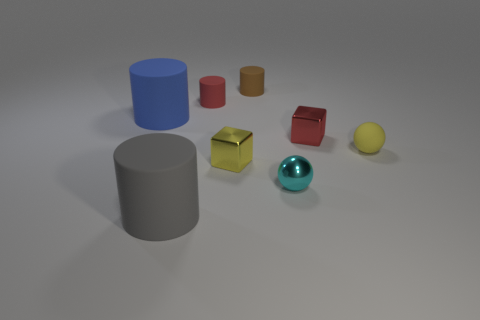What textures can be observed on the objects in the image? The objects display a variety of textures; the cylinders and cubes have smooth surfaces, while the spheres show a slight glossy or reflective texture, particularly noticeable on the metallic sphere.  Which object stands out the most due to its brightness or color? The teal metallic sphere stands out the most due to its bright and reflective surface, which catches the light differently compared to the more matte surfaces of the other objects. 